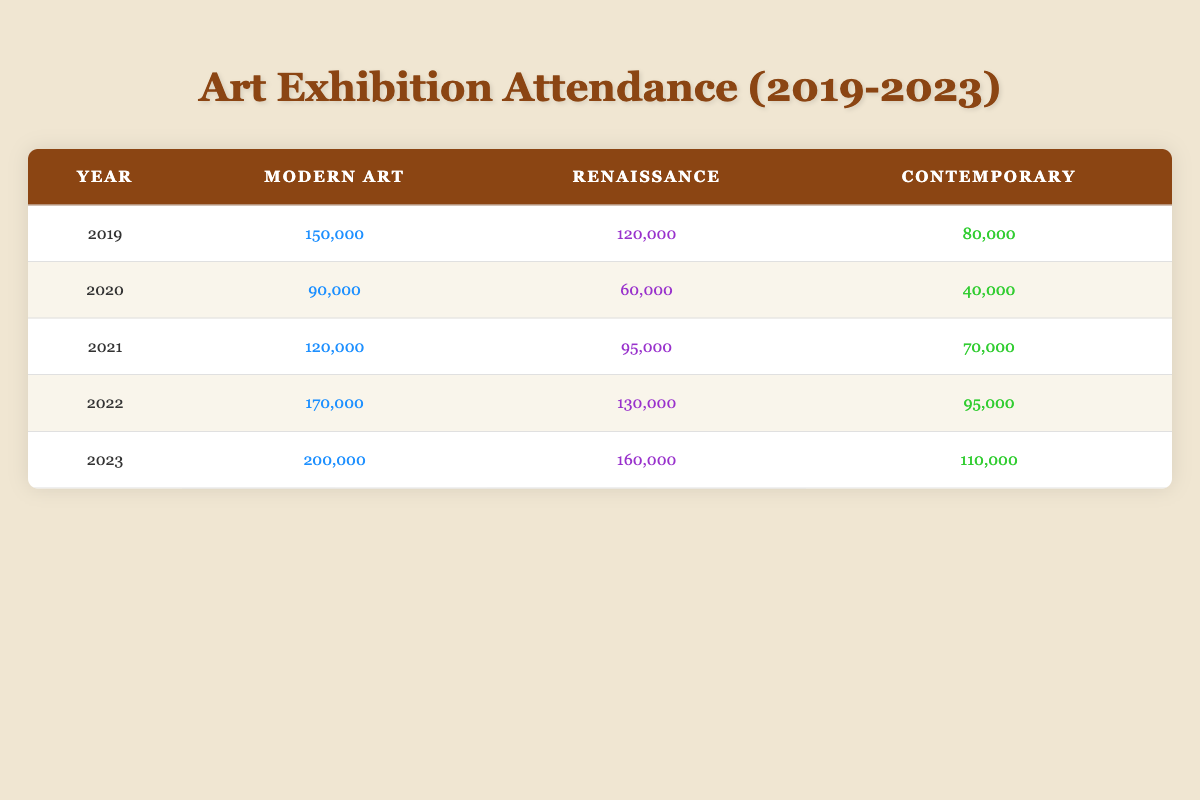What was the attendance for Modern Art in 2022? According to the table, the attendance for Modern Art in 2022 is listed as 170,000.
Answer: 170,000 What genre had the highest attendance in 2023? In 2023, Modern Art has the highest attendance at 200,000, compared to 160,000 for Renaissance and 110,000 for Contemporary.
Answer: Modern Art What was the total attendance for Renaissance exhibitions from 2019 to 2023? The attendance for Renaissance exhibitions from 2019 to 2023 is calculated as follows: 120,000 (2019) + 60,000 (2020) + 95,000 (2021) + 130,000 (2022) + 160,000 (2023) = 565,000.
Answer: 565,000 Is it true that Contemporary exhibitions had more attendance than Renaissance exhibitions in 2021? In 2021, Contemporary exhibitions had an attendance of 70,000, while Renaissance exhibitions had 95,000. Since 70,000 is less than 95,000, this statement is false.
Answer: No What year had the greatest overall exhibition attendance across all genres? To determine the year with the greatest overall attendance, we total the attendance for each year: 2019 (150,000 + 120,000 + 80,000 = 350,000), 2020 (90,000 + 60,000 + 40,000 = 190,000), 2021 (120,000 + 95,000 + 70,000 = 285,000), 2022 (170,000 + 130,000 + 95,000 = 395,000), and 2023 (200,000 + 160,000 + 110,000 = 470,000). The year with the highest total is 2023 with 470,000.
Answer: 2023 